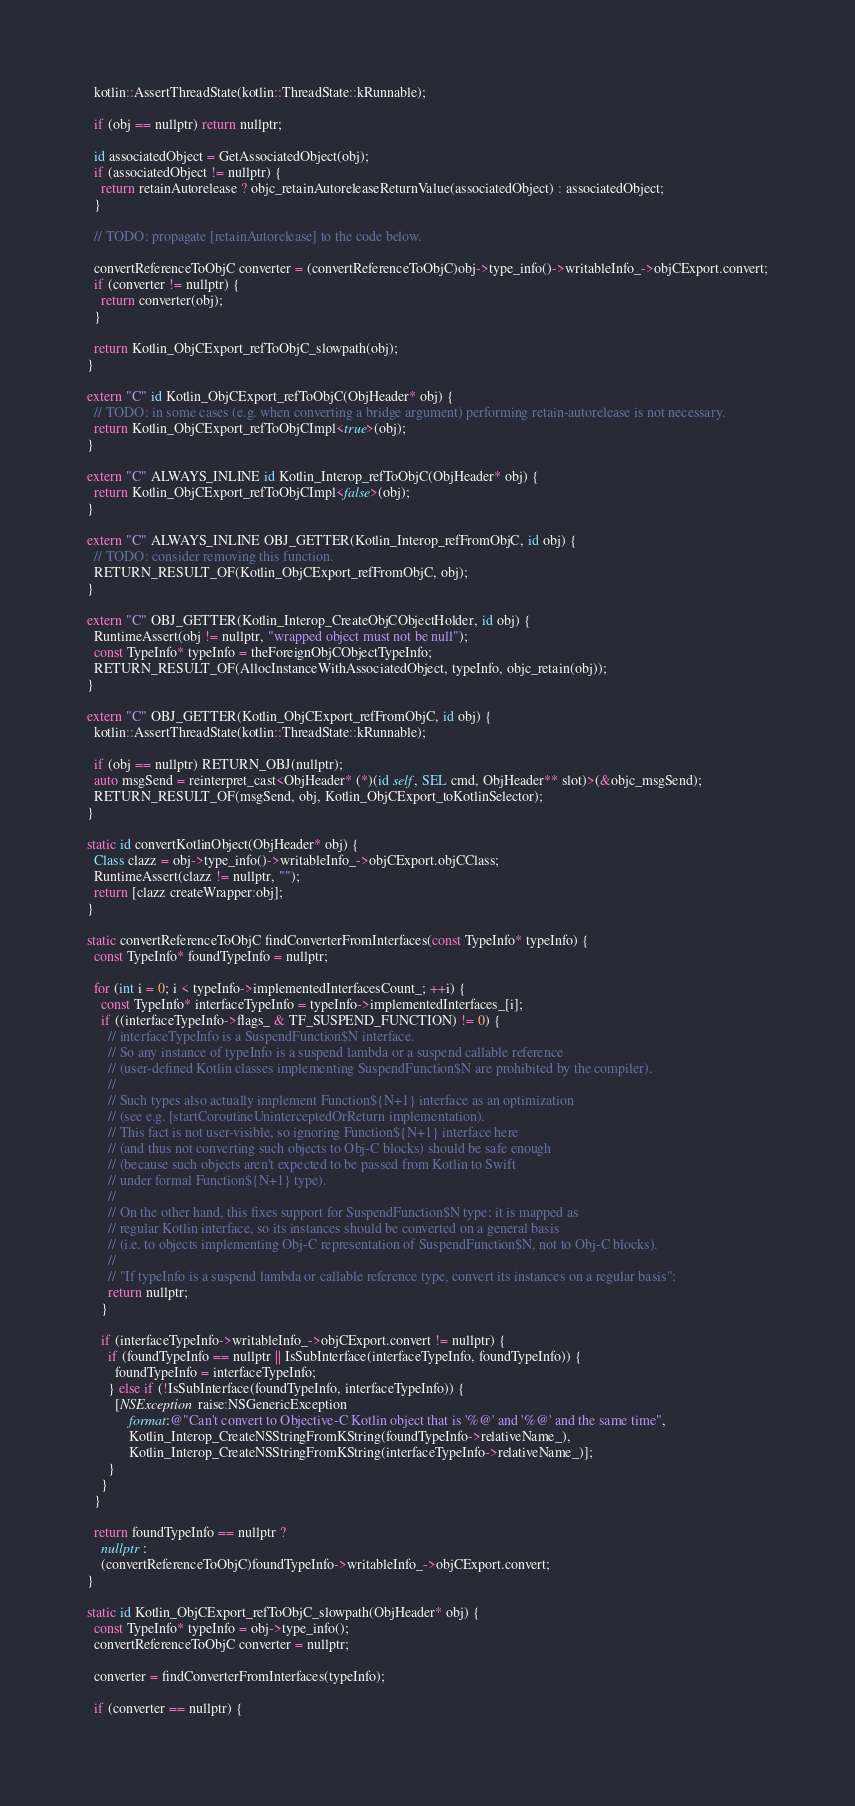<code> <loc_0><loc_0><loc_500><loc_500><_ObjectiveC_>  kotlin::AssertThreadState(kotlin::ThreadState::kRunnable);

  if (obj == nullptr) return nullptr;

  id associatedObject = GetAssociatedObject(obj);
  if (associatedObject != nullptr) {
    return retainAutorelease ? objc_retainAutoreleaseReturnValue(associatedObject) : associatedObject;
  }

  // TODO: propagate [retainAutorelease] to the code below.

  convertReferenceToObjC converter = (convertReferenceToObjC)obj->type_info()->writableInfo_->objCExport.convert;
  if (converter != nullptr) {
    return converter(obj);
  }

  return Kotlin_ObjCExport_refToObjC_slowpath(obj);
}

extern "C" id Kotlin_ObjCExport_refToObjC(ObjHeader* obj) {
  // TODO: in some cases (e.g. when converting a bridge argument) performing retain-autorelease is not necessary.
  return Kotlin_ObjCExport_refToObjCImpl<true>(obj);
}

extern "C" ALWAYS_INLINE id Kotlin_Interop_refToObjC(ObjHeader* obj) {
  return Kotlin_ObjCExport_refToObjCImpl<false>(obj);
}

extern "C" ALWAYS_INLINE OBJ_GETTER(Kotlin_Interop_refFromObjC, id obj) {
  // TODO: consider removing this function.
  RETURN_RESULT_OF(Kotlin_ObjCExport_refFromObjC, obj);
}

extern "C" OBJ_GETTER(Kotlin_Interop_CreateObjCObjectHolder, id obj) {
  RuntimeAssert(obj != nullptr, "wrapped object must not be null");
  const TypeInfo* typeInfo = theForeignObjCObjectTypeInfo;
  RETURN_RESULT_OF(AllocInstanceWithAssociatedObject, typeInfo, objc_retain(obj));
}

extern "C" OBJ_GETTER(Kotlin_ObjCExport_refFromObjC, id obj) {
  kotlin::AssertThreadState(kotlin::ThreadState::kRunnable);

  if (obj == nullptr) RETURN_OBJ(nullptr);
  auto msgSend = reinterpret_cast<ObjHeader* (*)(id self, SEL cmd, ObjHeader** slot)>(&objc_msgSend);
  RETURN_RESULT_OF(msgSend, obj, Kotlin_ObjCExport_toKotlinSelector);
}

static id convertKotlinObject(ObjHeader* obj) {
  Class clazz = obj->type_info()->writableInfo_->objCExport.objCClass;
  RuntimeAssert(clazz != nullptr, "");
  return [clazz createWrapper:obj];
}

static convertReferenceToObjC findConverterFromInterfaces(const TypeInfo* typeInfo) {
  const TypeInfo* foundTypeInfo = nullptr;

  for (int i = 0; i < typeInfo->implementedInterfacesCount_; ++i) {
    const TypeInfo* interfaceTypeInfo = typeInfo->implementedInterfaces_[i];
    if ((interfaceTypeInfo->flags_ & TF_SUSPEND_FUNCTION) != 0) {
      // interfaceTypeInfo is a SuspendFunction$N interface.
      // So any instance of typeInfo is a suspend lambda or a suspend callable reference
      // (user-defined Kotlin classes implementing SuspendFunction$N are prohibited by the compiler).
      //
      // Such types also actually implement Function${N+1} interface as an optimization
      // (see e.g. [startCoroutineUninterceptedOrReturn implementation).
      // This fact is not user-visible, so ignoring Function${N+1} interface here
      // (and thus not converting such objects to Obj-C blocks) should be safe enough
      // (because such objects aren't expected to be passed from Kotlin to Swift
      // under formal Function${N+1} type).
      //
      // On the other hand, this fixes support for SuspendFunction$N type: it is mapped as
      // regular Kotlin interface, so its instances should be converted on a general basis
      // (i.e. to objects implementing Obj-C representation of SuspendFunction$N, not to Obj-C blocks).
      //
      // "If typeInfo is a suspend lambda or callable reference type, convert its instances on a regular basis":
      return nullptr;
    }

    if (interfaceTypeInfo->writableInfo_->objCExport.convert != nullptr) {
      if (foundTypeInfo == nullptr || IsSubInterface(interfaceTypeInfo, foundTypeInfo)) {
        foundTypeInfo = interfaceTypeInfo;
      } else if (!IsSubInterface(foundTypeInfo, interfaceTypeInfo)) {
        [NSException raise:NSGenericException
            format:@"Can't convert to Objective-C Kotlin object that is '%@' and '%@' and the same time",
            Kotlin_Interop_CreateNSStringFromKString(foundTypeInfo->relativeName_),
            Kotlin_Interop_CreateNSStringFromKString(interfaceTypeInfo->relativeName_)];
      }
    }
  }

  return foundTypeInfo == nullptr ?
    nullptr :
    (convertReferenceToObjC)foundTypeInfo->writableInfo_->objCExport.convert;
}

static id Kotlin_ObjCExport_refToObjC_slowpath(ObjHeader* obj) {
  const TypeInfo* typeInfo = obj->type_info();
  convertReferenceToObjC converter = nullptr;

  converter = findConverterFromInterfaces(typeInfo);

  if (converter == nullptr) {</code> 